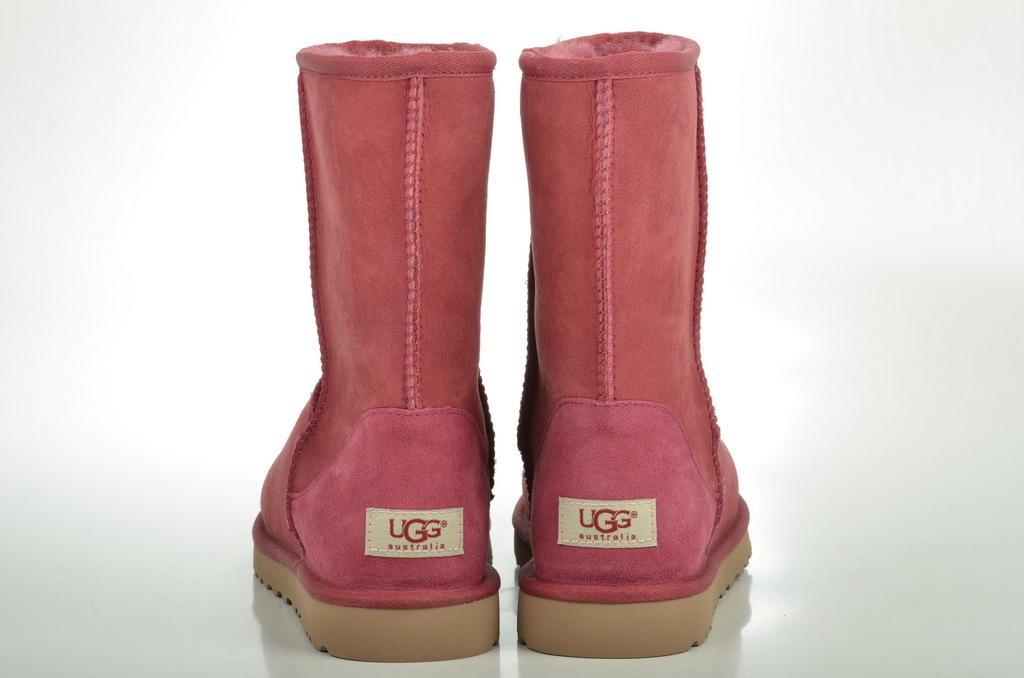Describe this image in one or two sentences. In this picture I can see pair of footwear and I can see white color background. 